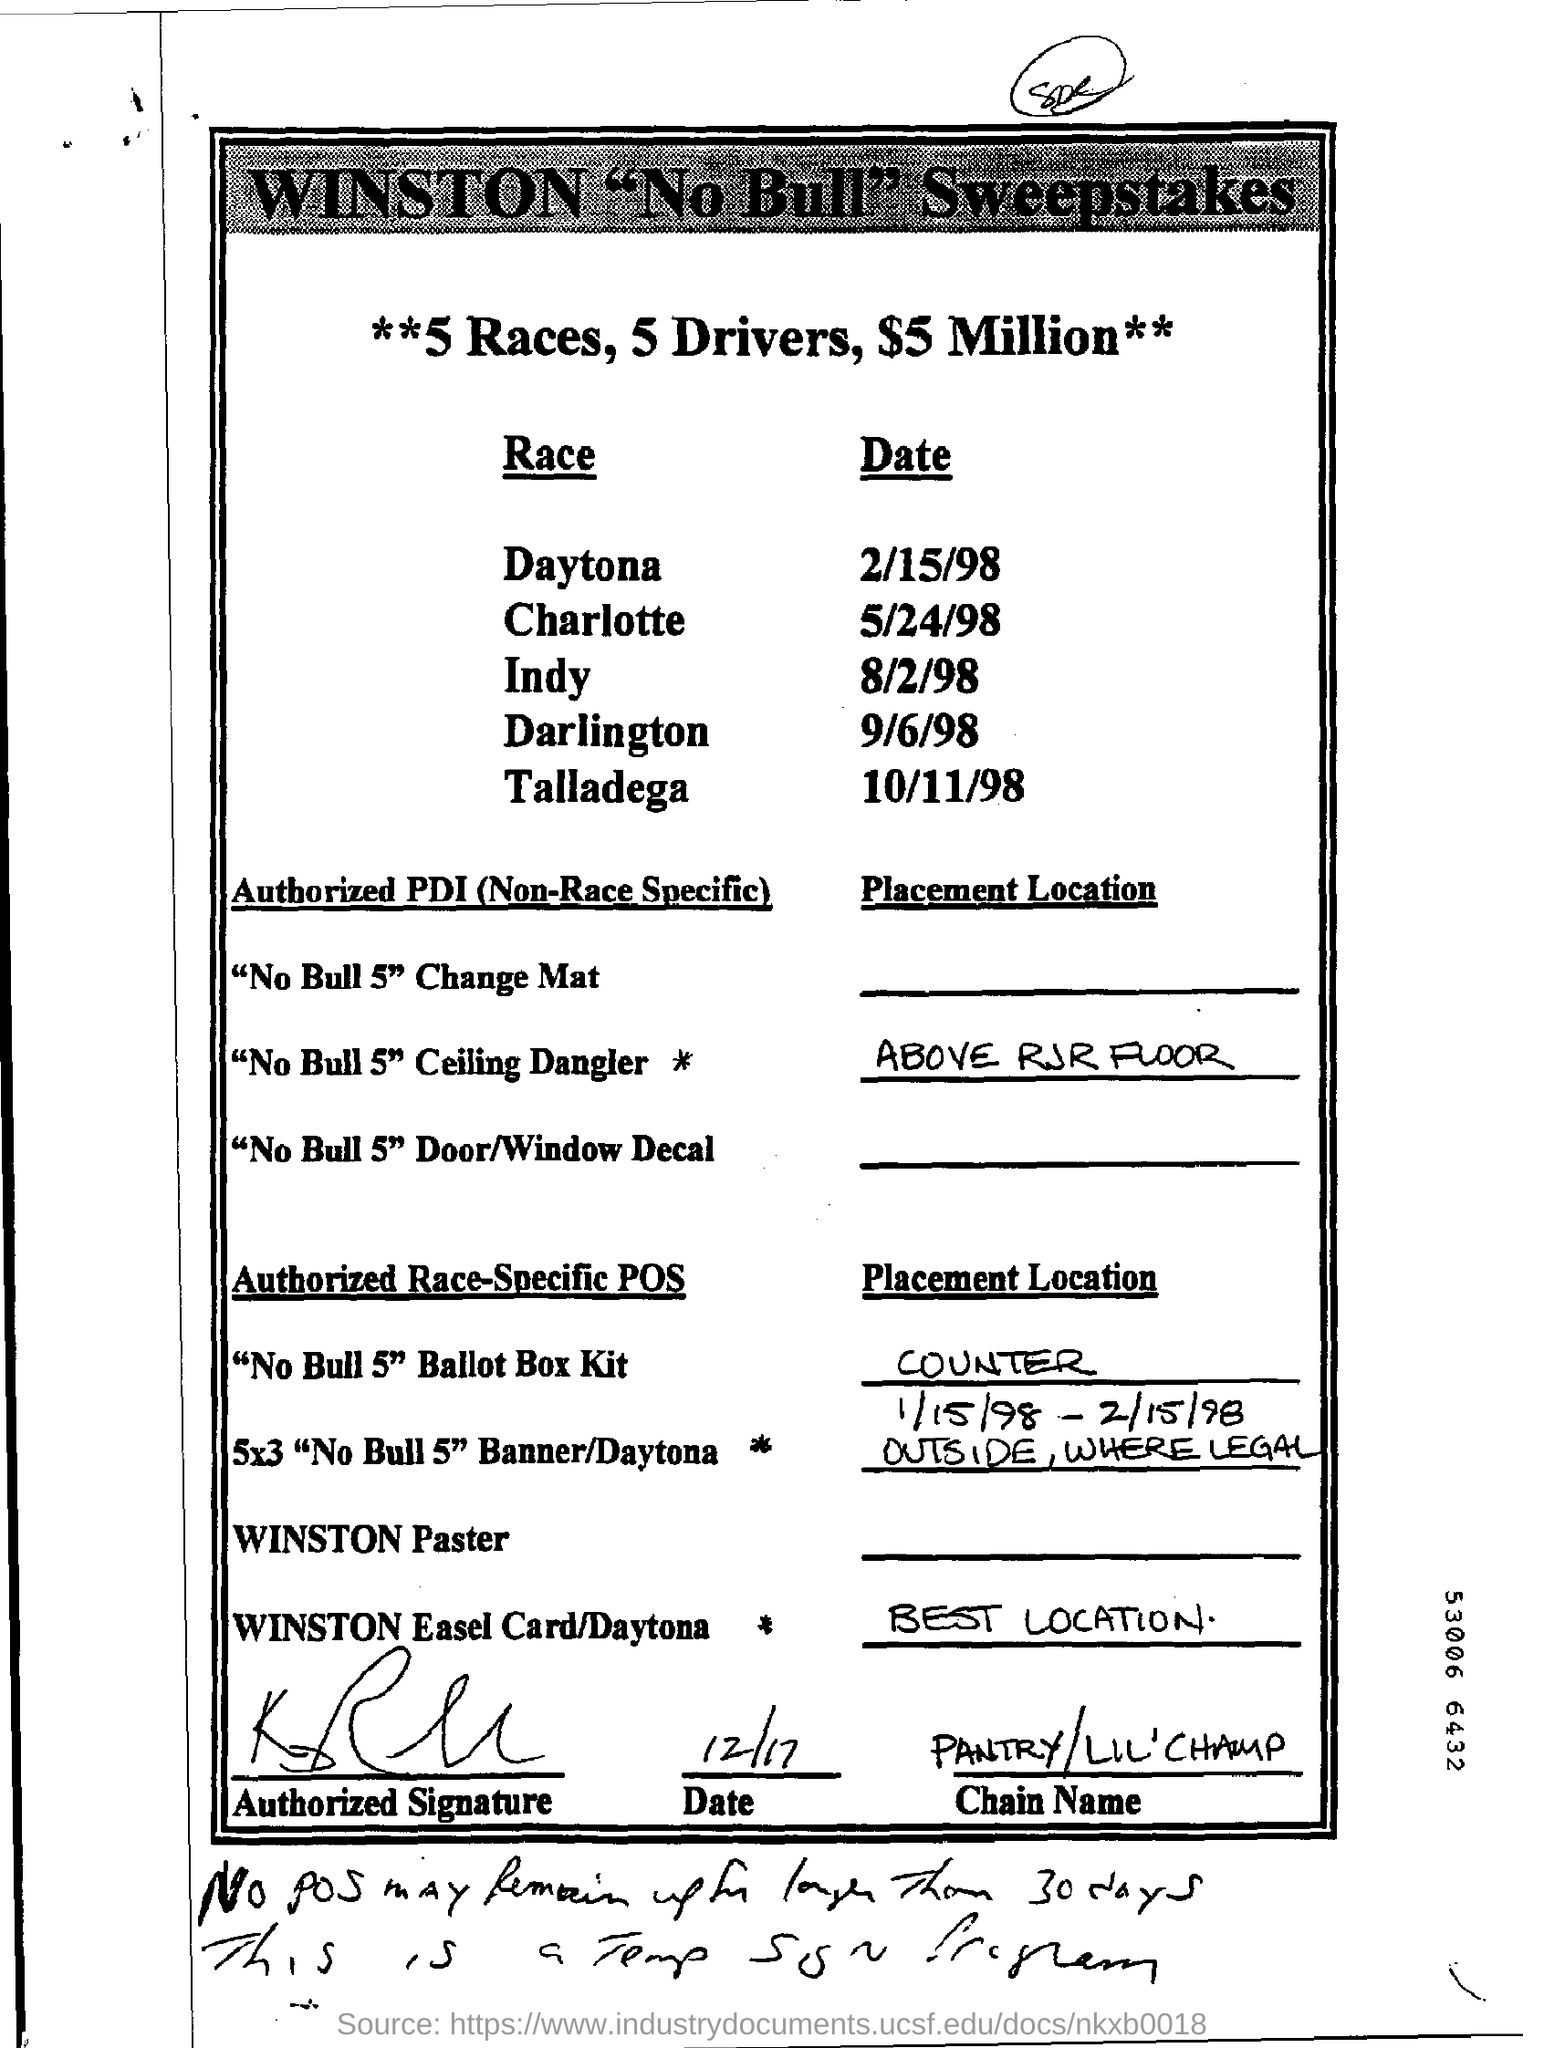When is Indy race ?
Your response must be concise. 8/2/98. What is the place location of "No Bull 5" Ceiling Dangler ?
Your answer should be very brief. ABOVE RJR FLOOR. When is Daytona race
Ensure brevity in your answer.  2/15/98. What is the chain name ?
Offer a very short reply. Pantry / lil' champ. 